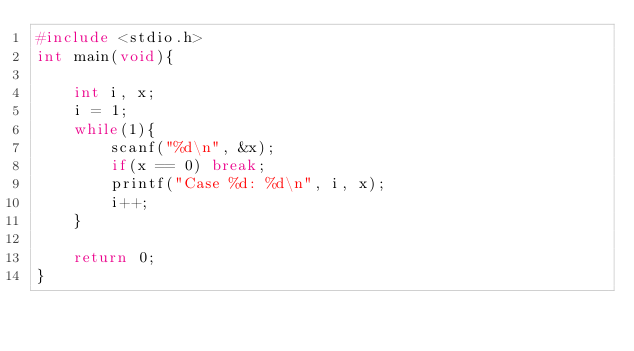Convert code to text. <code><loc_0><loc_0><loc_500><loc_500><_C_>#include <stdio.h>
int main(void){
    
    int i, x;
    i = 1;
    while(1){
        scanf("%d\n", &x);
        if(x == 0) break;
        printf("Case %d: %d\n", i, x);
        i++;
    }
    
    return 0;
}
</code> 